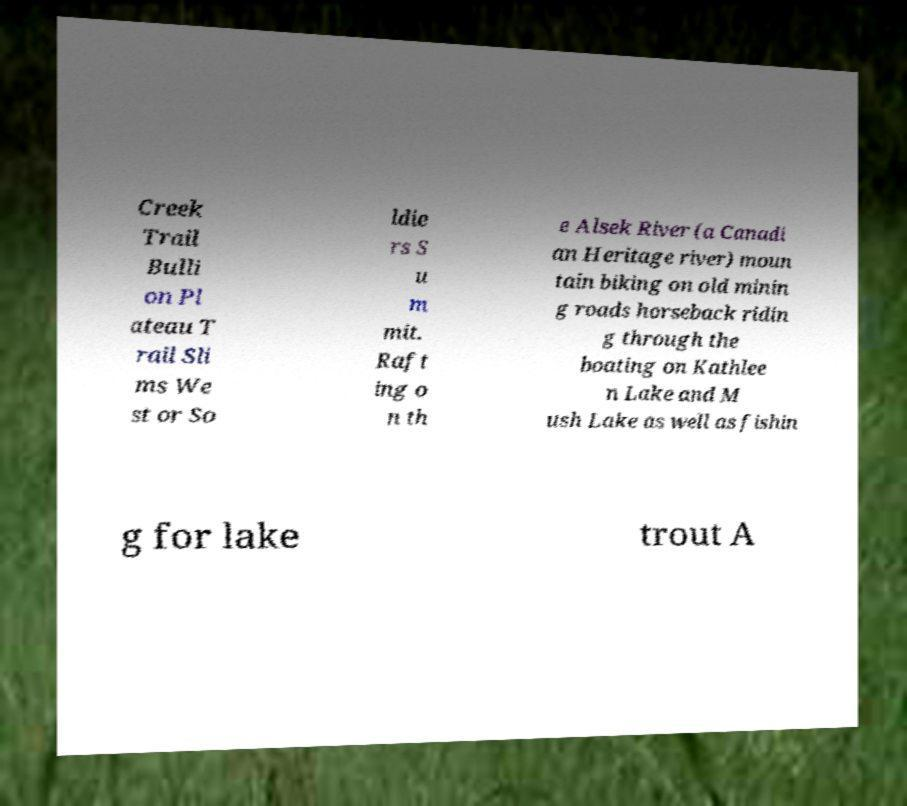For documentation purposes, I need the text within this image transcribed. Could you provide that? Creek Trail Bulli on Pl ateau T rail Sli ms We st or So ldie rs S u m mit. Raft ing o n th e Alsek River (a Canadi an Heritage river) moun tain biking on old minin g roads horseback ridin g through the boating on Kathlee n Lake and M ush Lake as well as fishin g for lake trout A 